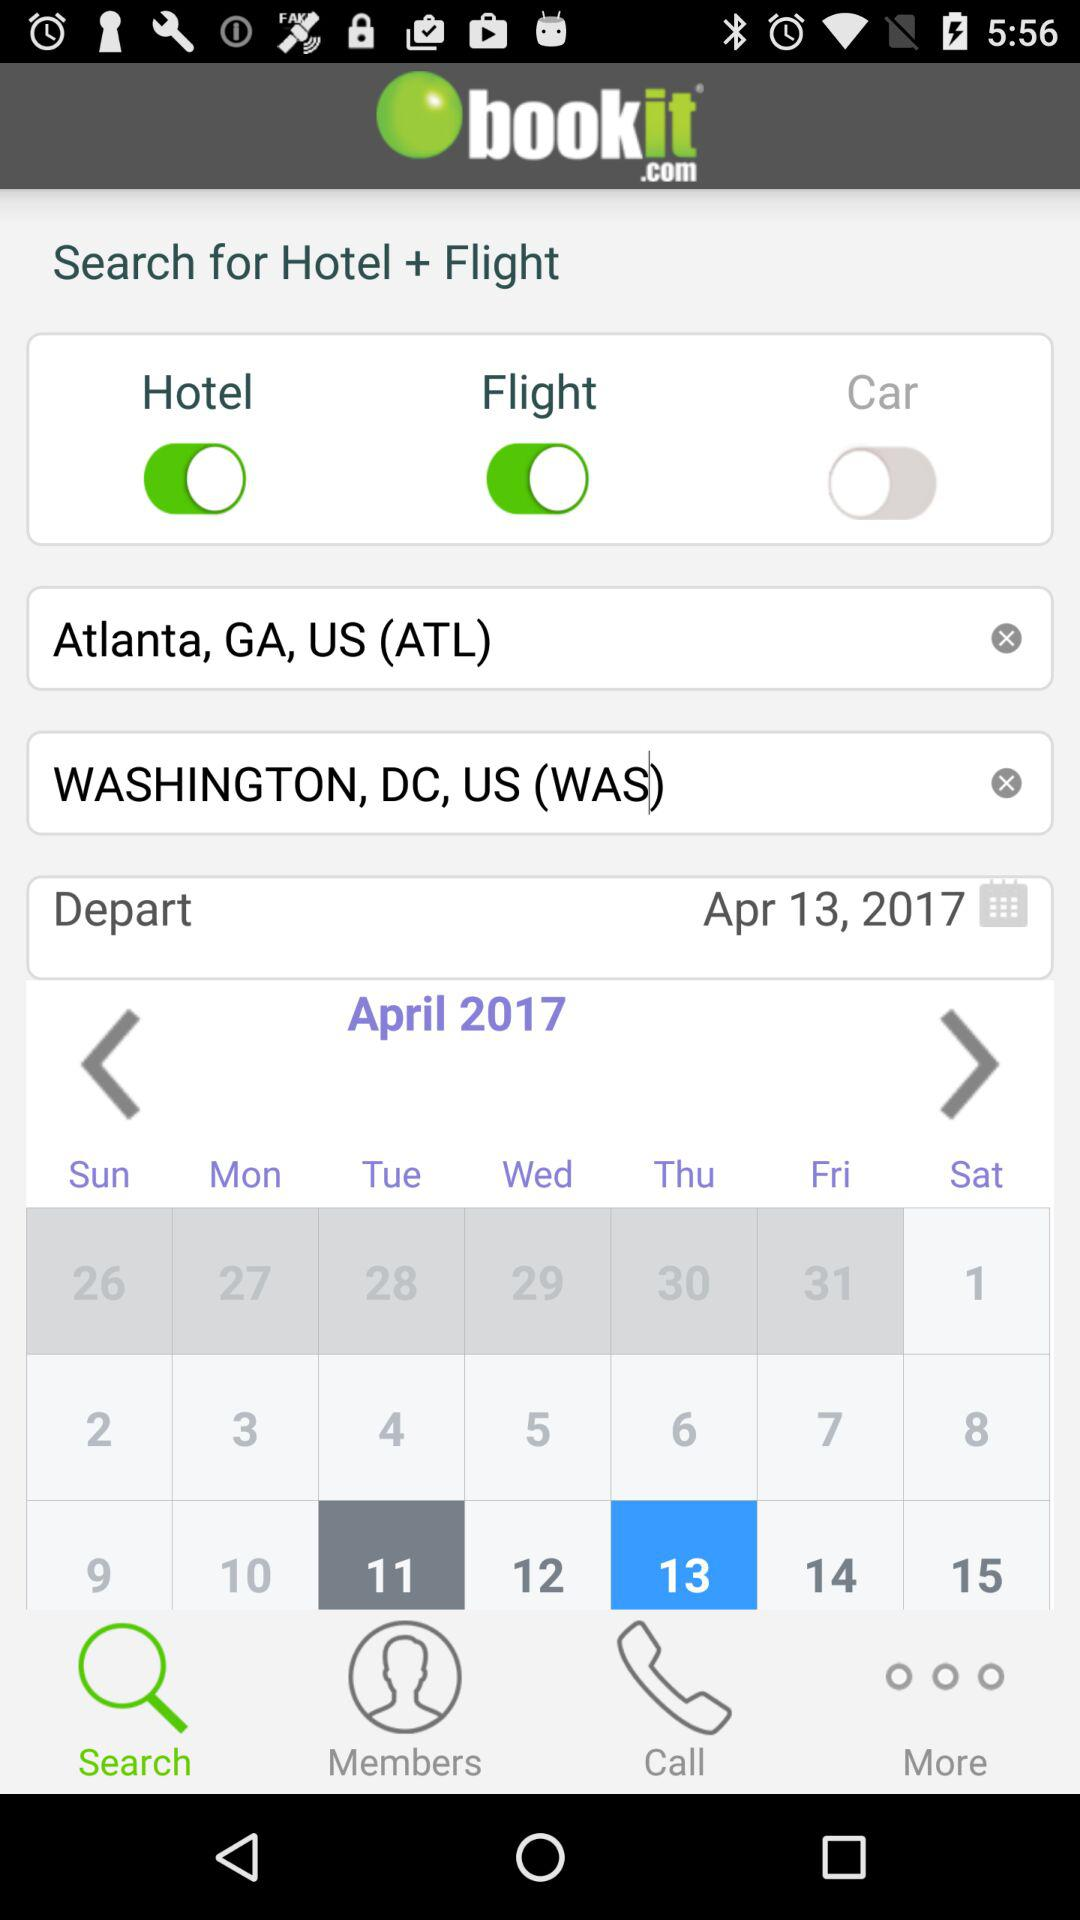What is the app name? The app name is "bookit.com". 